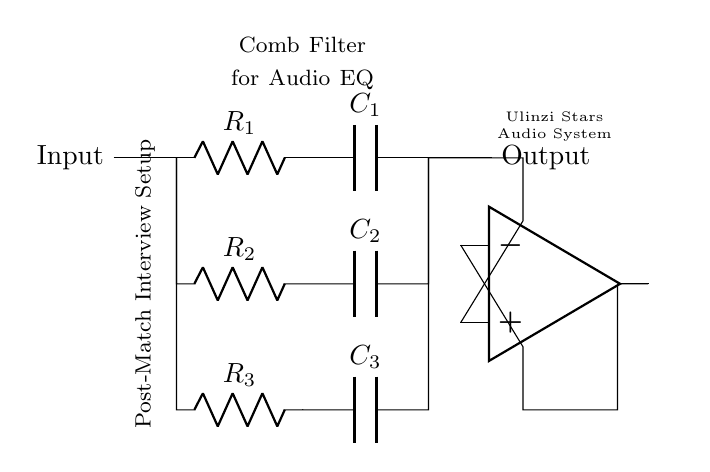What type of circuit is represented? The circuit is a comb filter used for audio equalization, as indicated by the title in the diagram.
Answer: Comb filter What components are used in the top branch? The components in the top branch are a resistor and a capacitor, specifically R1 and C1, as shown in the circuit.
Answer: R1, C1 How many resistors are in this circuit? There are three resistors in the circuit (R1, R2, R3), which can be counted directly from the diagram.
Answer: 3 What is the configuration of the op-amp? The op-amp is configured as a summing amplifier since it takes multiple voltage inputs from different branches.
Answer: Summing amplifier What is the purpose of the capacitors in this circuit? The capacitors serve to filter specific frequencies, which is a key function in a comb filter used for audio applications.
Answer: Frequency filtering What does the label “Post-Match Interview Setup” suggest about the circuit's usage? The label indicates that the circuit is designed for enhancing audio clarity during post-match interviews, suggesting its application in specific audio settings.
Answer: Enhancing audio clarity What is the significance of the Ulinzi Stars reference? The Ulinzi Stars reference likely denotes that this audio system is tailored specifically for the needs of the Ulinzi Stars football team's audio setup.
Answer: Tailored audio system 